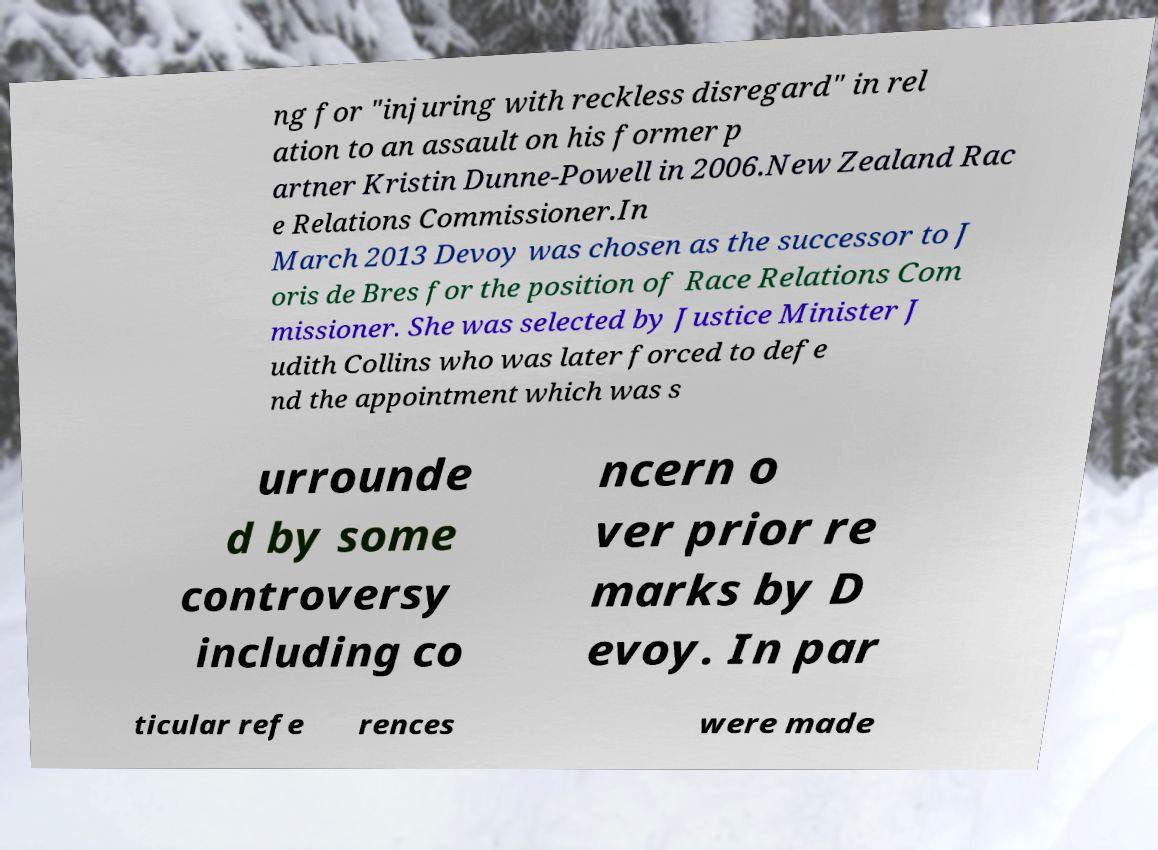Please identify and transcribe the text found in this image. ng for "injuring with reckless disregard" in rel ation to an assault on his former p artner Kristin Dunne-Powell in 2006.New Zealand Rac e Relations Commissioner.In March 2013 Devoy was chosen as the successor to J oris de Bres for the position of Race Relations Com missioner. She was selected by Justice Minister J udith Collins who was later forced to defe nd the appointment which was s urrounde d by some controversy including co ncern o ver prior re marks by D evoy. In par ticular refe rences were made 